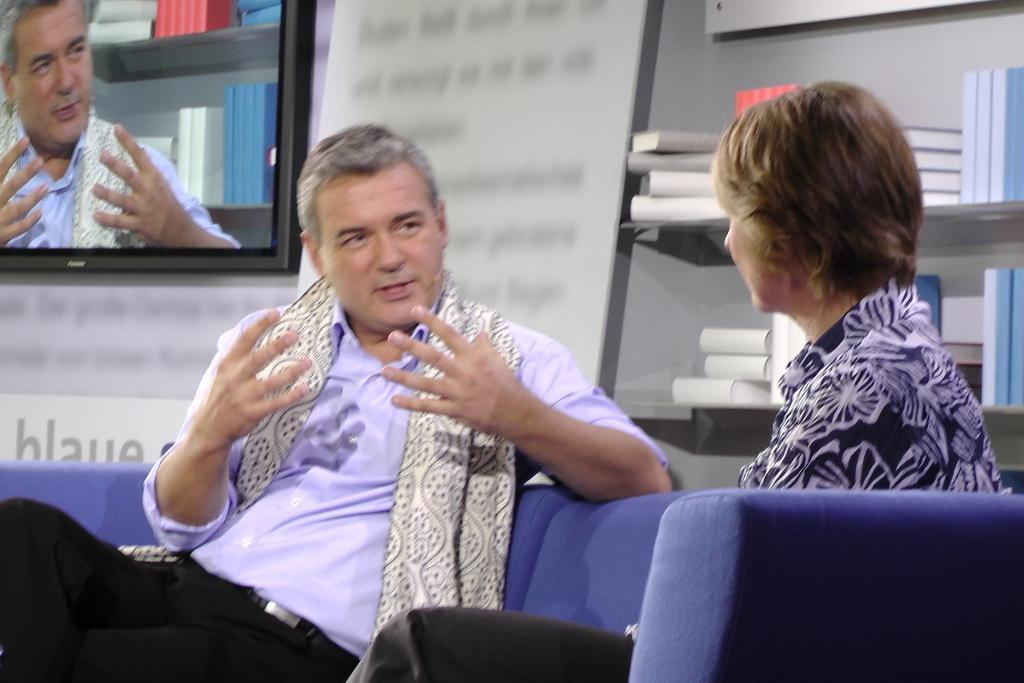Describe this image in one or two sentences. In this picture there is a man and a woman sitting on a sofa. There are many books in the shelf. There is a television. 